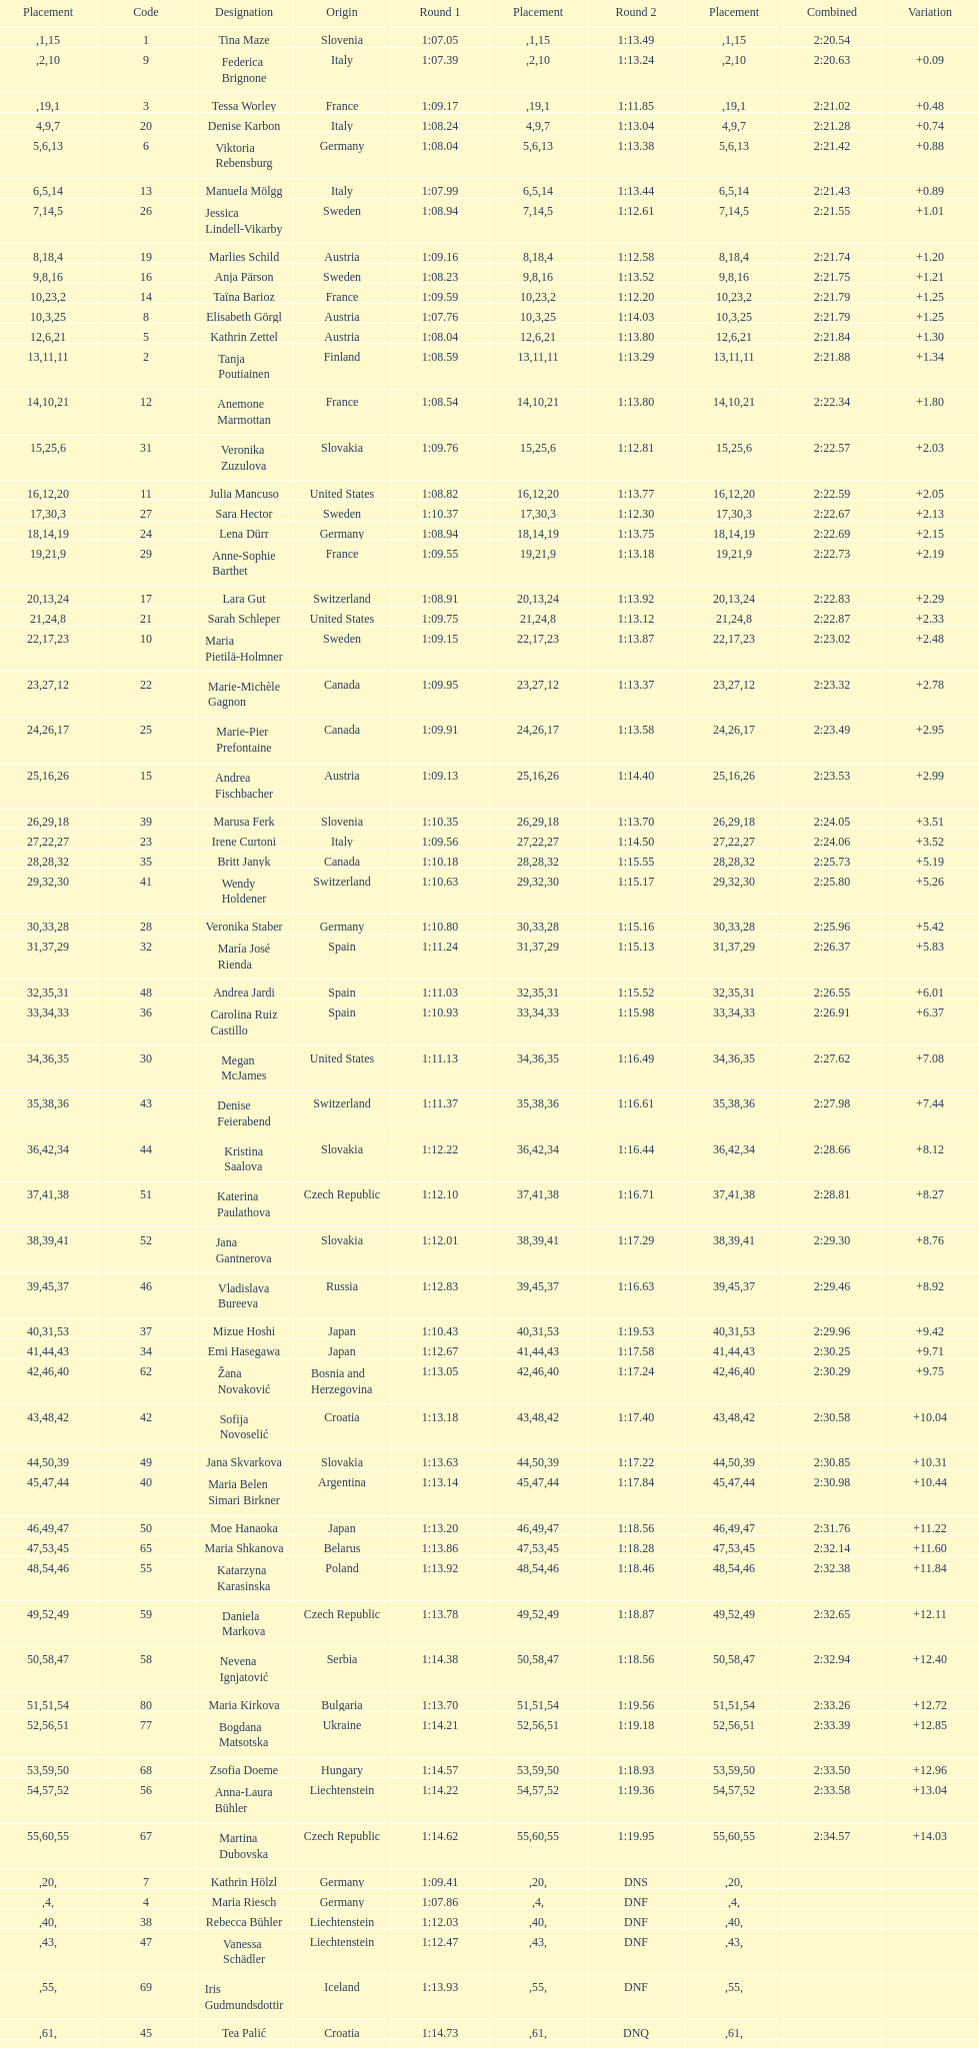What is the name before anja parson? Marlies Schild. 